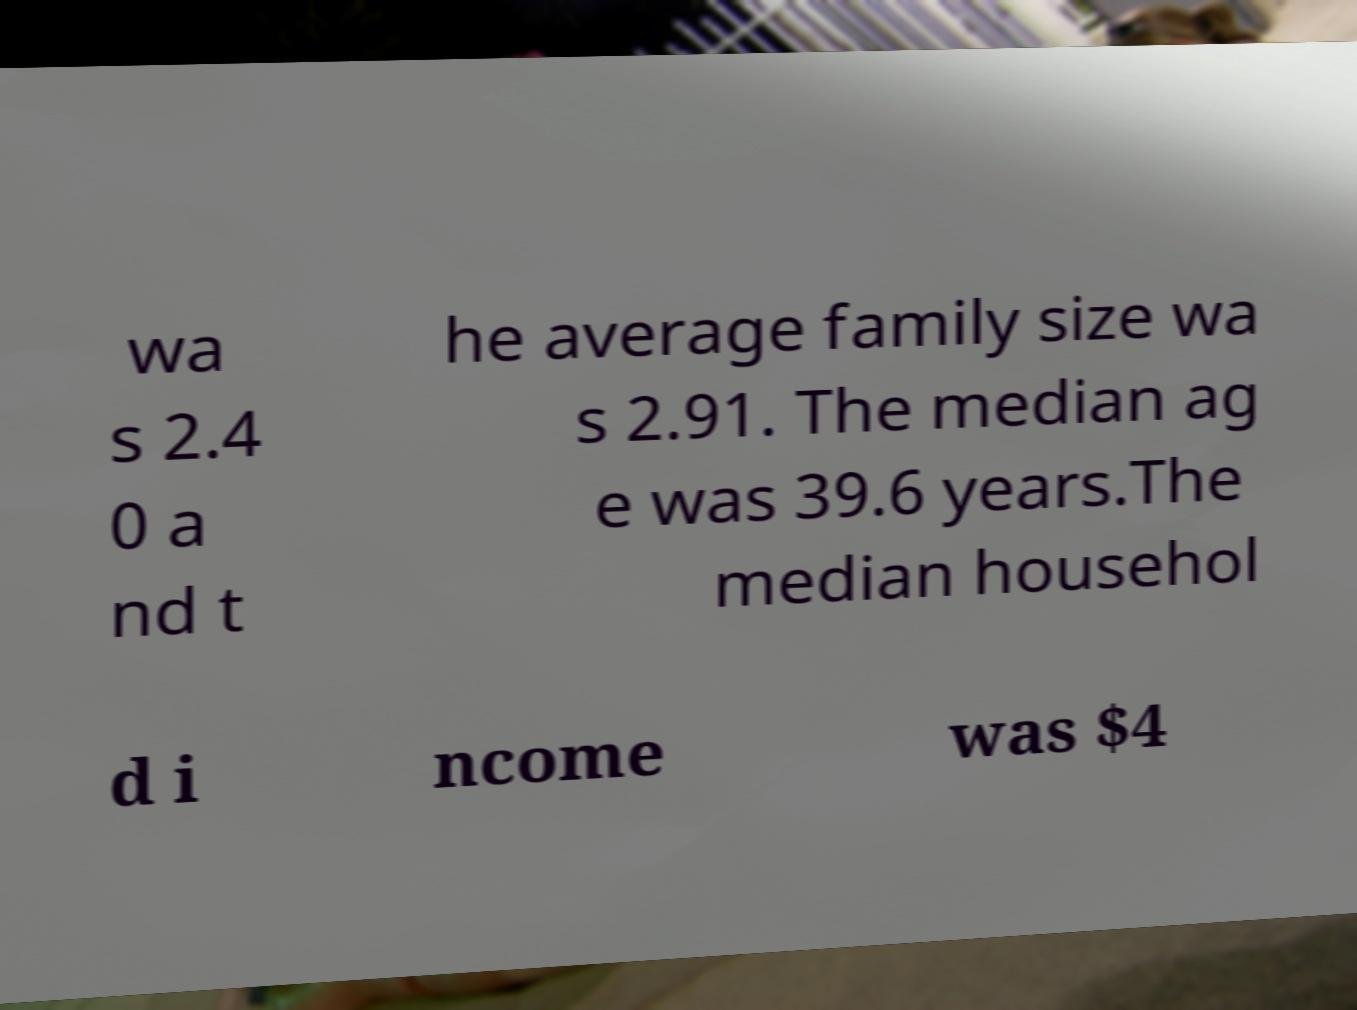Can you accurately transcribe the text from the provided image for me? wa s 2.4 0 a nd t he average family size wa s 2.91. The median ag e was 39.6 years.The median househol d i ncome was $4 